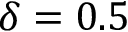Convert formula to latex. <formula><loc_0><loc_0><loc_500><loc_500>\delta = 0 . 5</formula> 